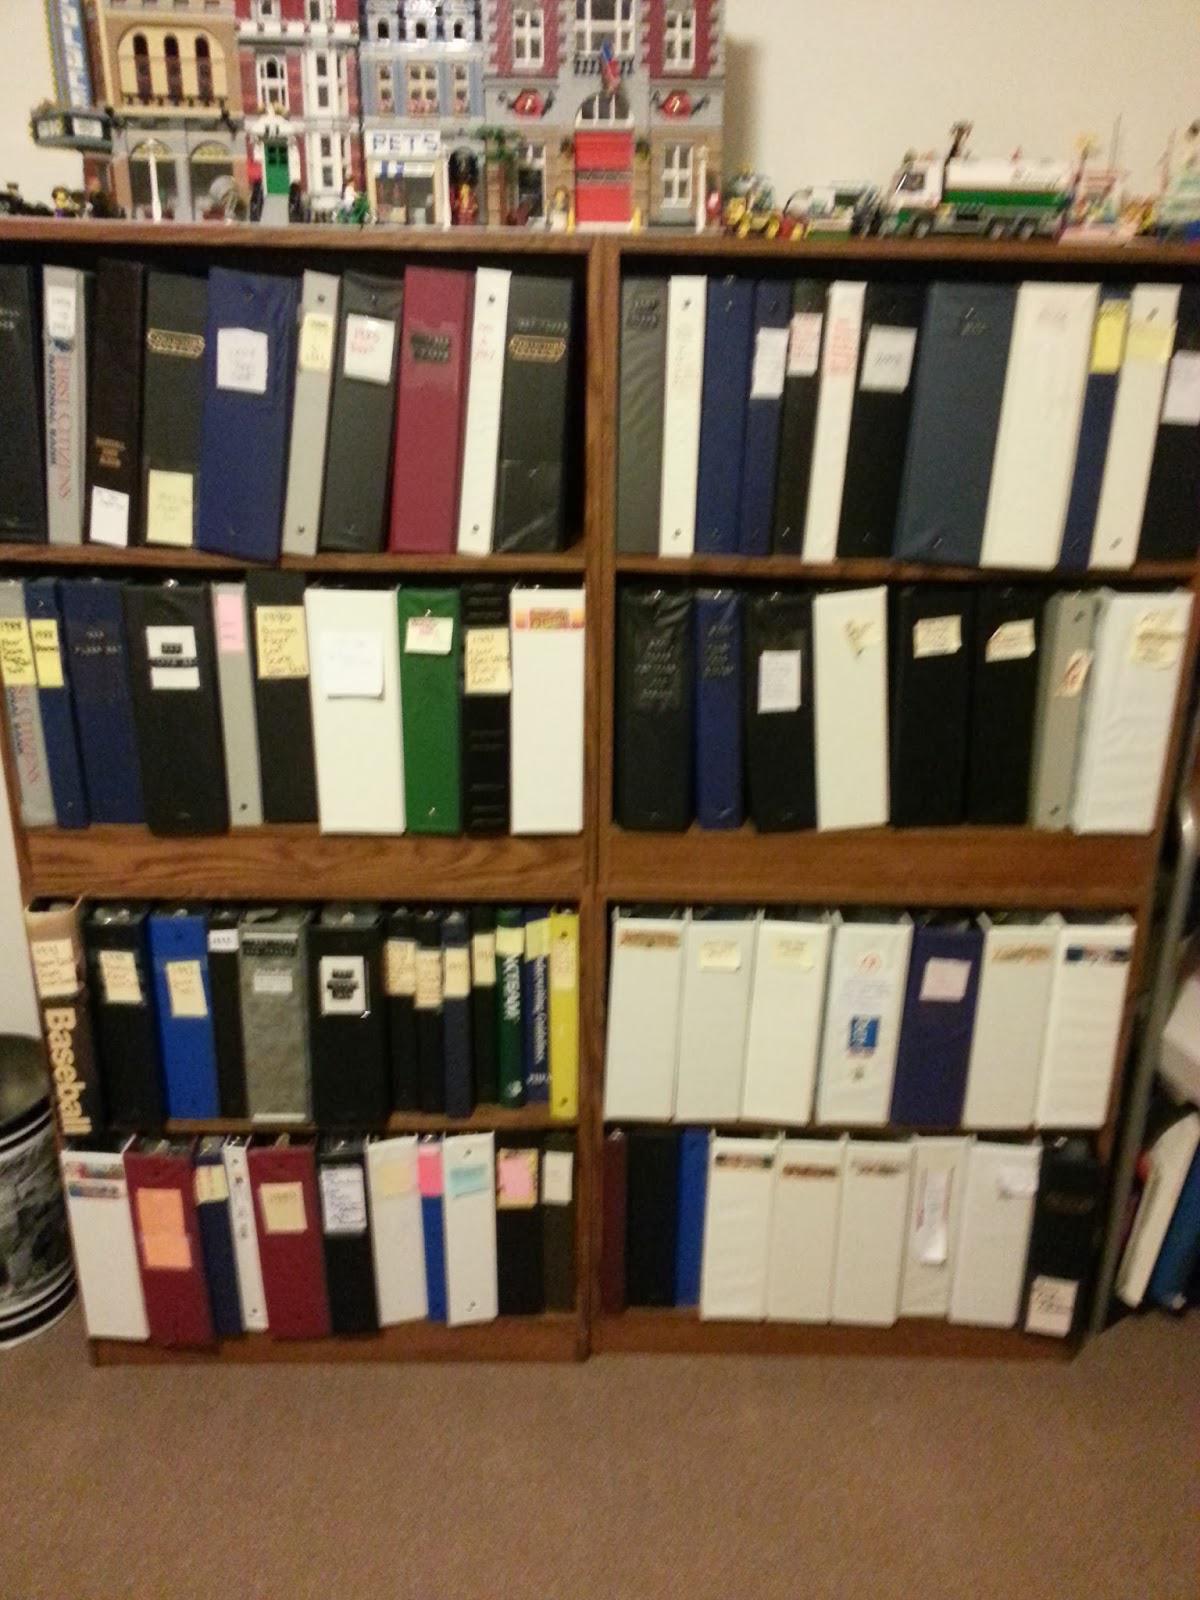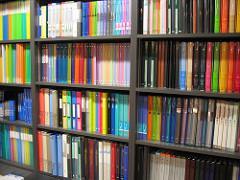The first image is the image on the left, the second image is the image on the right. Assess this claim about the two images: "Collector cards arranged in plastic pockets of notebook pages are shown in one image.". Correct or not? Answer yes or no. No. 